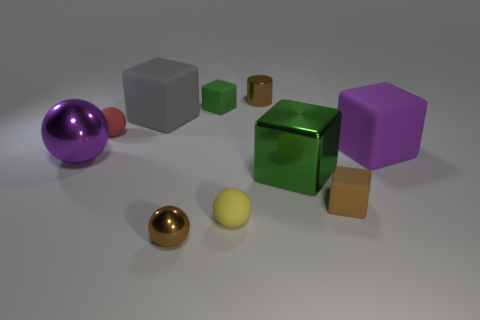Subtract all red spheres. How many spheres are left? 3 Subtract all blue cylinders. How many green blocks are left? 2 Subtract all brown balls. How many balls are left? 3 Subtract 3 blocks. How many blocks are left? 2 Subtract all green cylinders. Subtract all green cubes. How many cylinders are left? 1 Subtract all large metal things. Subtract all large shiny blocks. How many objects are left? 7 Add 8 large green things. How many large green things are left? 9 Add 7 purple matte blocks. How many purple matte blocks exist? 8 Subtract 0 red blocks. How many objects are left? 10 Subtract all cylinders. How many objects are left? 9 